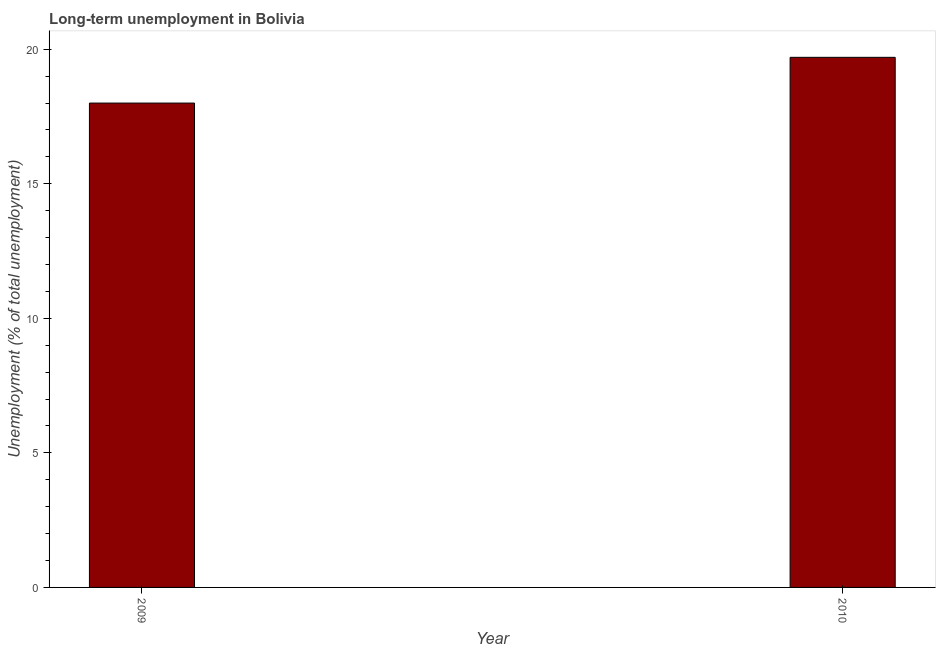What is the title of the graph?
Offer a very short reply. Long-term unemployment in Bolivia. What is the label or title of the Y-axis?
Ensure brevity in your answer.  Unemployment (% of total unemployment). What is the long-term unemployment in 2010?
Your response must be concise. 19.7. Across all years, what is the maximum long-term unemployment?
Your response must be concise. 19.7. In which year was the long-term unemployment maximum?
Make the answer very short. 2010. In which year was the long-term unemployment minimum?
Provide a short and direct response. 2009. What is the sum of the long-term unemployment?
Keep it short and to the point. 37.7. What is the difference between the long-term unemployment in 2009 and 2010?
Give a very brief answer. -1.7. What is the average long-term unemployment per year?
Offer a terse response. 18.85. What is the median long-term unemployment?
Offer a terse response. 18.85. Do a majority of the years between 2009 and 2010 (inclusive) have long-term unemployment greater than 10 %?
Give a very brief answer. Yes. What is the ratio of the long-term unemployment in 2009 to that in 2010?
Provide a succinct answer. 0.91. How many bars are there?
Ensure brevity in your answer.  2. Are all the bars in the graph horizontal?
Make the answer very short. No. What is the difference between two consecutive major ticks on the Y-axis?
Your response must be concise. 5. Are the values on the major ticks of Y-axis written in scientific E-notation?
Make the answer very short. No. What is the Unemployment (% of total unemployment) of 2010?
Provide a short and direct response. 19.7. What is the difference between the Unemployment (% of total unemployment) in 2009 and 2010?
Make the answer very short. -1.7. What is the ratio of the Unemployment (% of total unemployment) in 2009 to that in 2010?
Make the answer very short. 0.91. 